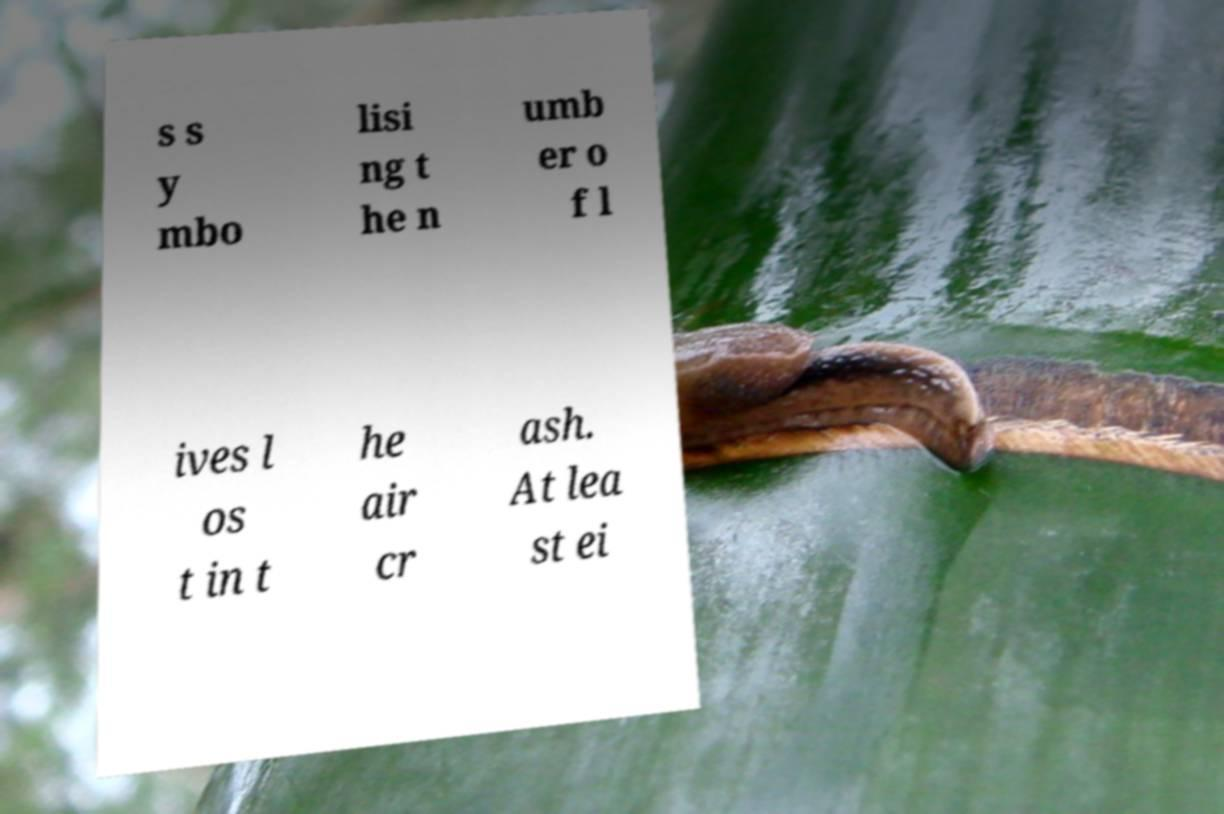Could you extract and type out the text from this image? s s y mbo lisi ng t he n umb er o f l ives l os t in t he air cr ash. At lea st ei 